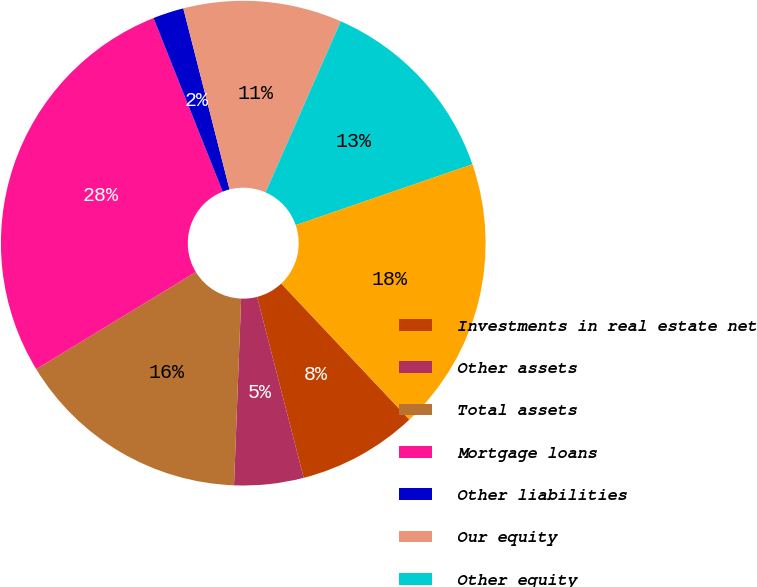Convert chart. <chart><loc_0><loc_0><loc_500><loc_500><pie_chart><fcel>Investments in real estate net<fcel>Other assets<fcel>Total assets<fcel>Mortgage loans<fcel>Other liabilities<fcel>Our equity<fcel>Other equity<fcel>Total liabilities and equity<nl><fcel>8.01%<fcel>4.62%<fcel>15.69%<fcel>27.66%<fcel>2.06%<fcel>10.57%<fcel>13.13%<fcel>18.25%<nl></chart> 